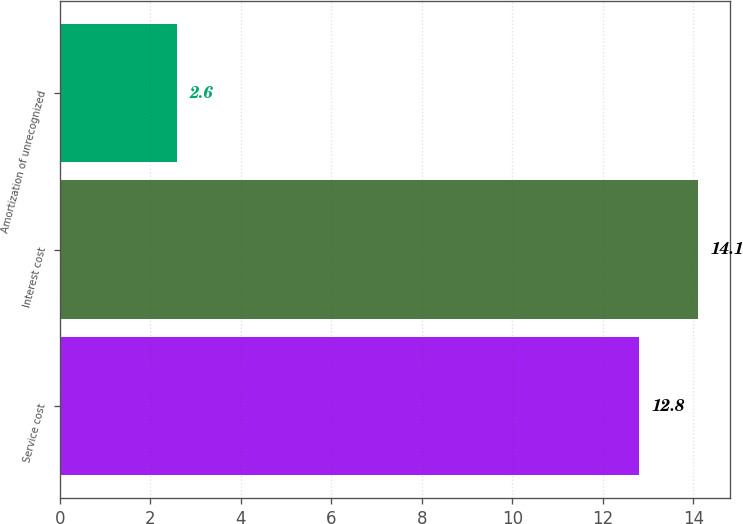<chart> <loc_0><loc_0><loc_500><loc_500><bar_chart><fcel>Service cost<fcel>Interest cost<fcel>Amortization of unrecognized<nl><fcel>12.8<fcel>14.1<fcel>2.6<nl></chart> 